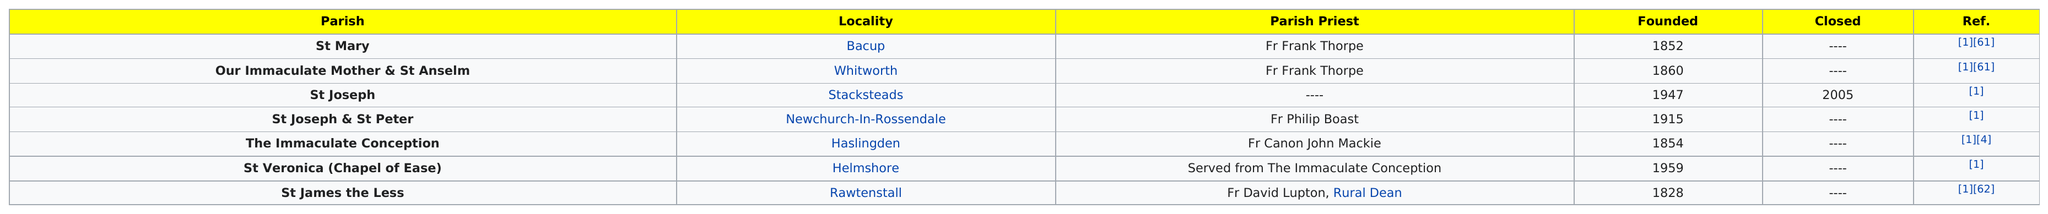Draw attention to some important aspects in this diagram. There were 4 parishes founded before 1900. The total number of parishes served by Fr. Frank Thorpe is two. Fr. Frank Thorpe served as the parish priest of two parishes during his tenure. St Mary was founded by Fr Frank Thorpe, but other than that, Our Immaculate Mother & St Anselm were the only other parishes founded by Fr Thorpe. St. James the Less was founded earlier than St. Joseph. 